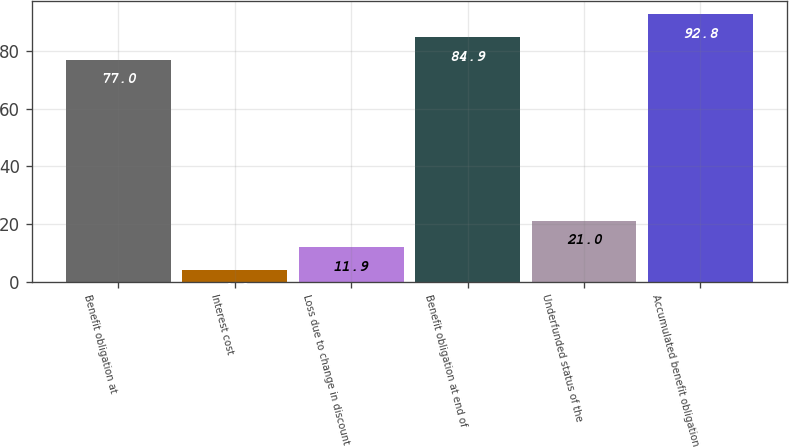Convert chart to OTSL. <chart><loc_0><loc_0><loc_500><loc_500><bar_chart><fcel>Benefit obligation at<fcel>Interest cost<fcel>Loss due to change in discount<fcel>Benefit obligation at end of<fcel>Underfunded status of the<fcel>Accumulated benefit obligation<nl><fcel>77<fcel>4<fcel>11.9<fcel>84.9<fcel>21<fcel>92.8<nl></chart> 